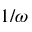<formula> <loc_0><loc_0><loc_500><loc_500>1 / \omega</formula> 